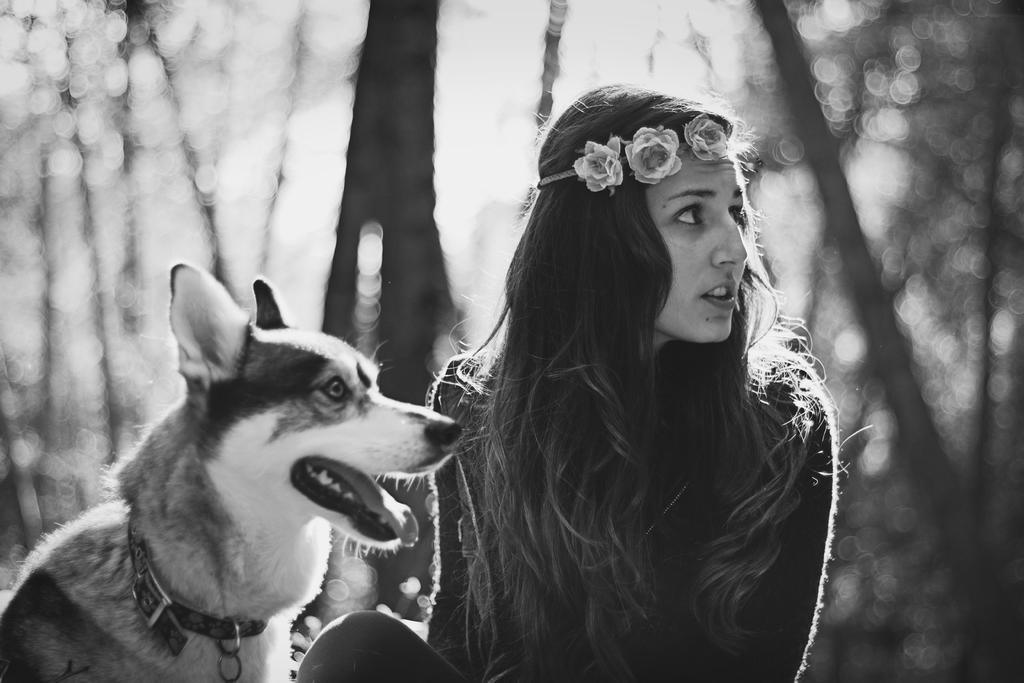Who is present in the image? There is a woman in the image. What other living creature can be seen in the image? There is a dog in the image. What can be seen in the background of the image? There are trees in the background of the image, although they are blurry. What health benefits does the caption on the image provide? There is no caption present in the image, so it is not possible to determine any health benefits. 